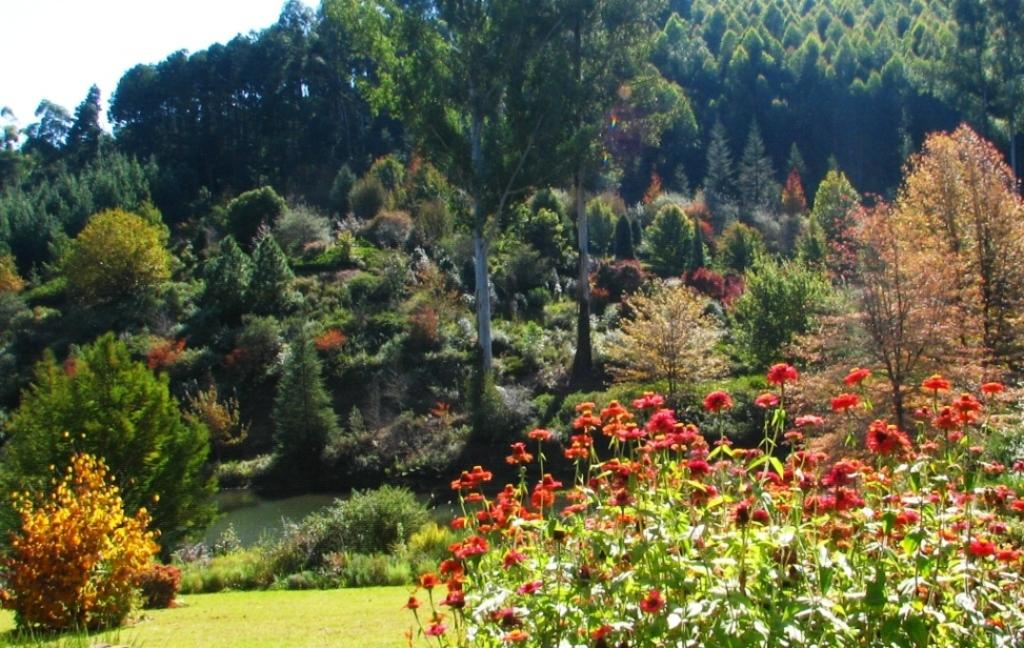What type of vegetation is at the bottom of the image? There are plants with flowers and grass at the bottom of the image. What can be seen in the background of the image? There are trees, plants, and the sky visible in the background of the image. What type of joke is being told by the roof in the image? There is no roof or joke present in the image. What kind of nut can be seen growing on the plants in the image? There are no nuts visible in the image; it features plants with flowers and grass. 